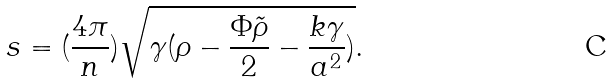<formula> <loc_0><loc_0><loc_500><loc_500>s = ( \frac { 4 \pi } { n } ) \sqrt { \gamma ( \rho - \frac { \Phi \tilde { \rho } } { 2 } - \frac { k \gamma } { a ^ { 2 } } ) } .</formula> 